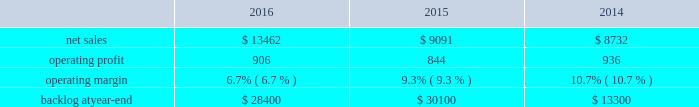2015 compared to 2014 mfc 2019s net sales in 2015 decreased $ 322 million , or 5% ( 5 % ) , compared to the same period in 2014 .
The decrease was attributable to lower net sales of approximately $ 345 million for air and missile defense programs due to fewer deliveries ( primarily pac-3 ) and lower volume ( primarily thaad ) ; and approximately $ 85 million for tactical missile programs due to fewer deliveries ( primarily guided multiple launch rocket system ( gmlrs ) ) and joint air-to-surface standoff missile , partially offset by increased deliveries for hellfire .
These decreases were partially offset by higher net sales of approximately $ 55 million for energy solutions programs due to increased volume .
Mfc 2019s operating profit in 2015 decreased $ 62 million , or 5% ( 5 % ) , compared to 2014 .
The decrease was attributable to lower operating profit of approximately $ 100 million for fire control programs due primarily to lower risk retirements ( primarily lantirn and sniper ) ; and approximately $ 65 million for tactical missile programs due to lower risk retirements ( primarily hellfire and gmlrs ) and fewer deliveries .
These decreases were partially offset by higher operating profit of approximately $ 75 million for air and missile defense programs due to increased risk retirements ( primarily thaad ) .
Adjustments not related to volume , including net profit booking rate adjustments and other matters , were approximately $ 60 million lower in 2015 compared to 2014 .
Backlog backlog decreased in 2016 compared to 2015 primarily due to lower orders on pac-3 , hellfire , and jassm .
Backlog increased in 2015 compared to 2014 primarily due to higher orders on pac-3 , lantirn/sniper and certain tactical missile programs , partially offset by lower orders on thaad .
Trends we expect mfc 2019s net sales to increase in the mid-single digit percentage range in 2017 as compared to 2016 driven primarily by our air and missile defense programs .
Operating profit is expected to be flat or increase slightly .
Accordingly , operating profit margin is expected to decline from 2016 levels as a result of contract mix and fewer risk retirements in 2017 compared to 2016 .
Rotary and mission systems as previously described , on november 6 , 2015 , we acquired sikorsky and aligned the sikorsky business under our rms business segment .
The 2015 results of the acquired sikorsky business have been included in our financial results from the november 6 , 2015 acquisition date through december 31 , 2015 .
As a result , our consolidated operating results and rms business segment operating results for the year ended december 31 , 2015 do not reflect a full year of sikorsky operations .
Our rms business segment provides design , manufacture , service and support for a variety of military and civil helicopters , ship and submarine mission and combat systems ; mission systems and sensors for rotary and fixed-wing aircraft ; sea and land-based missile defense systems ; radar systems ; the littoral combat ship ( lcs ) ; simulation and training services ; and unmanned systems and technologies .
In addition , rms supports the needs of government customers in cybersecurity and delivers communication and command and control capabilities through complex mission solutions for defense applications .
Rms 2019 major programs include black hawk and seahawk helicopters , aegis combat system ( aegis ) , lcs , space fence , advanced hawkeye radar system , tpq-53 radar system , ch-53k development helicopter , and vh-92a helicopter program .
Rms 2019 operating results included the following ( in millions ) : .
2016 compared to 2015 rms 2019 net sales in 2016 increased $ 4.4 billion , or 48% ( 48 % ) , compared to 2015 .
The increase was primarily attributable to higher net sales of approximately $ 4.6 billion from sikorsky , which was acquired on november 6 , 2015 .
Net sales for 2015 include sikorsky 2019s results subsequent to the acquisition date , net of certain revenue adjustments required to account for the acquisition of this business .
This increase was partially offset by lower net sales of approximately $ 70 million for training .
What were average net sales for rms in millions between 2014 and 2016? 
Computations: table_average(net sales, none)
Answer: 10428.33333. 